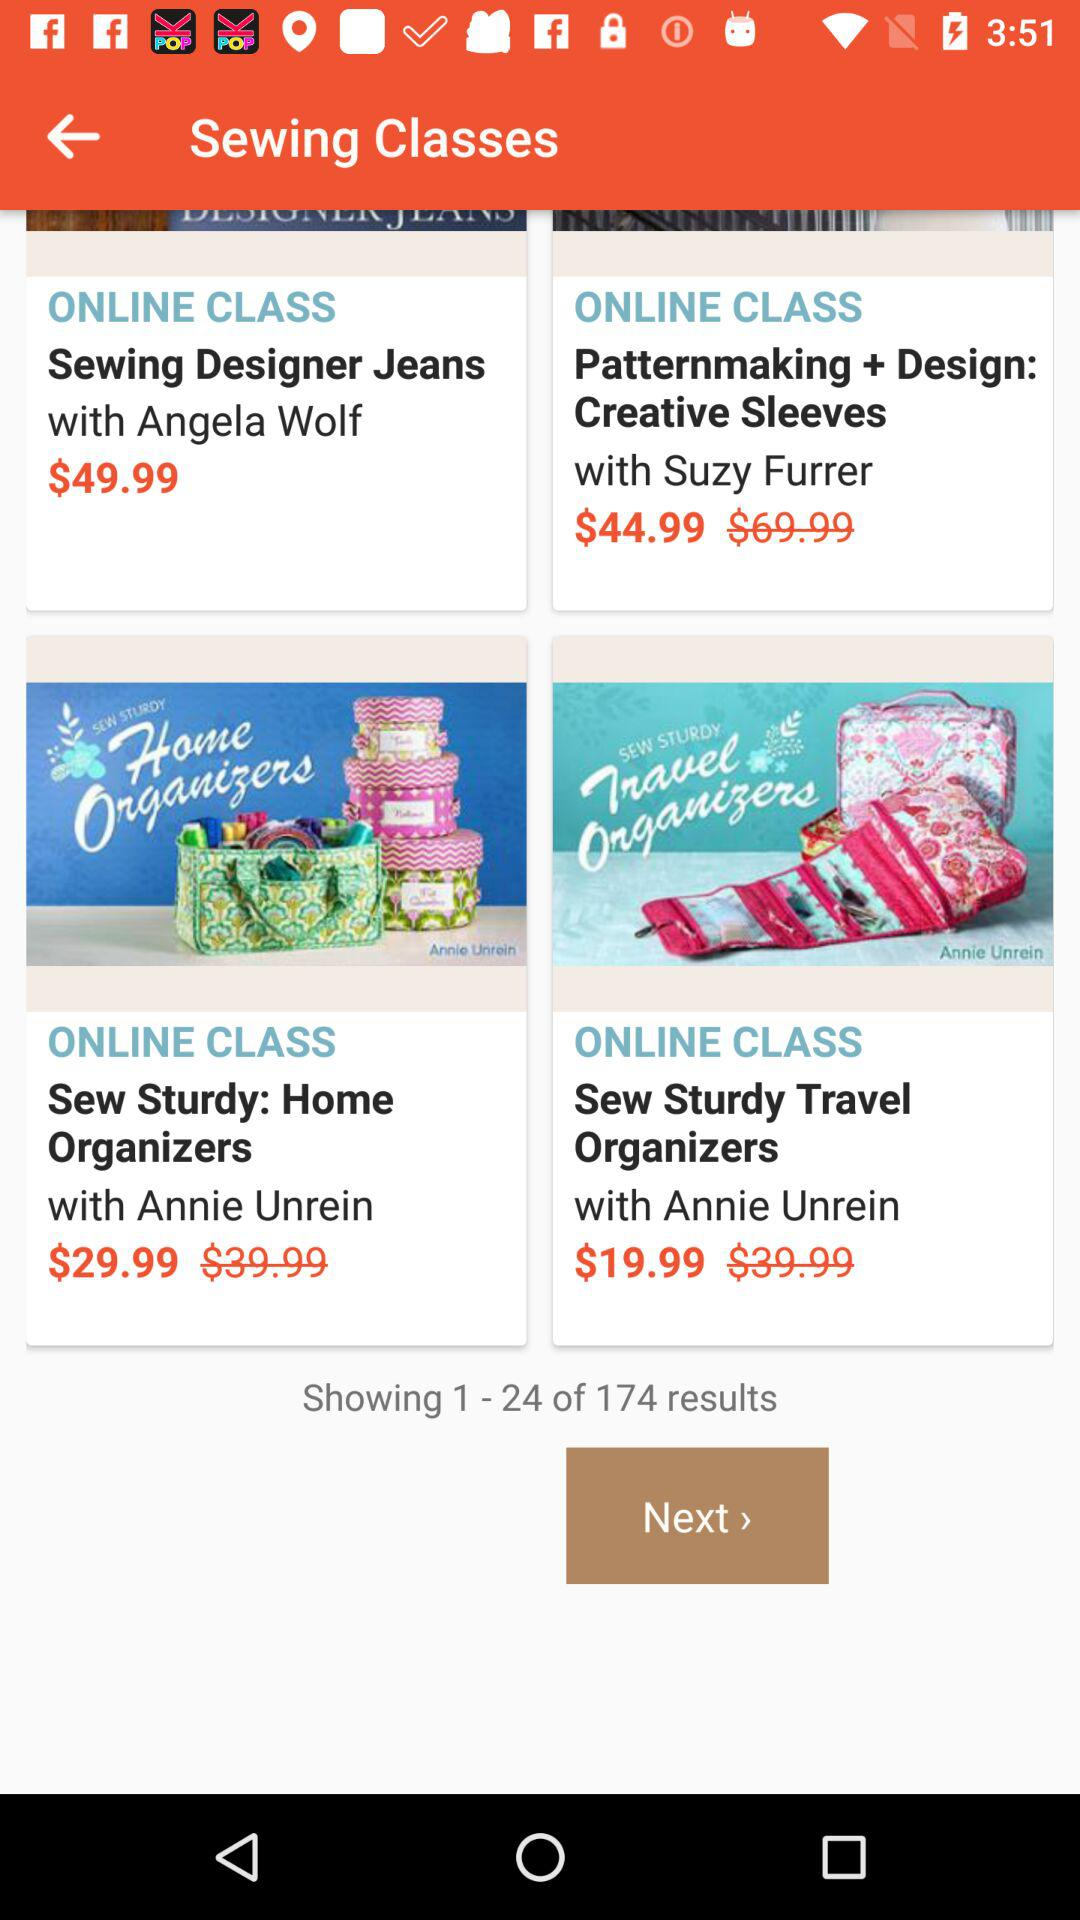Who is the author of the Sew Sturdy Travel Organizers? The author is "Annie Unrein". 